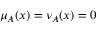Convert formula to latex. <formula><loc_0><loc_0><loc_500><loc_500>\mu _ { A } ( x ) = \nu _ { A } ( x ) = 0</formula> 